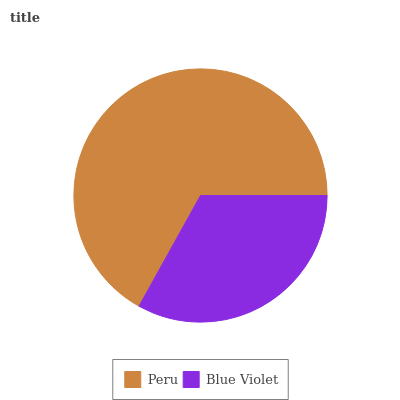Is Blue Violet the minimum?
Answer yes or no. Yes. Is Peru the maximum?
Answer yes or no. Yes. Is Blue Violet the maximum?
Answer yes or no. No. Is Peru greater than Blue Violet?
Answer yes or no. Yes. Is Blue Violet less than Peru?
Answer yes or no. Yes. Is Blue Violet greater than Peru?
Answer yes or no. No. Is Peru less than Blue Violet?
Answer yes or no. No. Is Peru the high median?
Answer yes or no. Yes. Is Blue Violet the low median?
Answer yes or no. Yes. Is Blue Violet the high median?
Answer yes or no. No. Is Peru the low median?
Answer yes or no. No. 